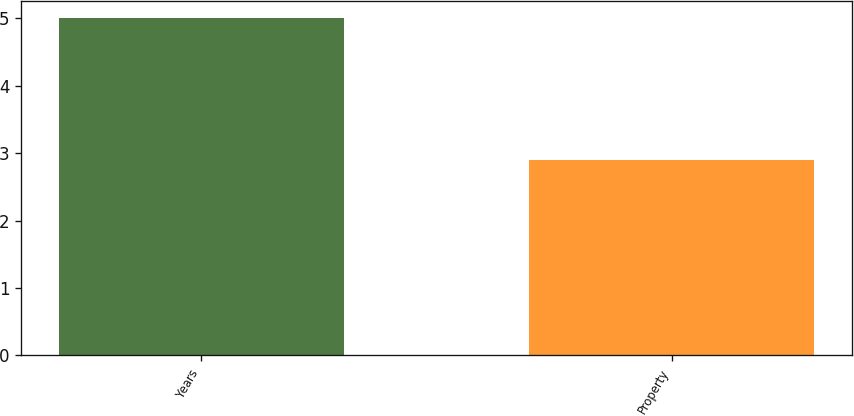<chart> <loc_0><loc_0><loc_500><loc_500><bar_chart><fcel>Years<fcel>Property<nl><fcel>5<fcel>2.9<nl></chart> 